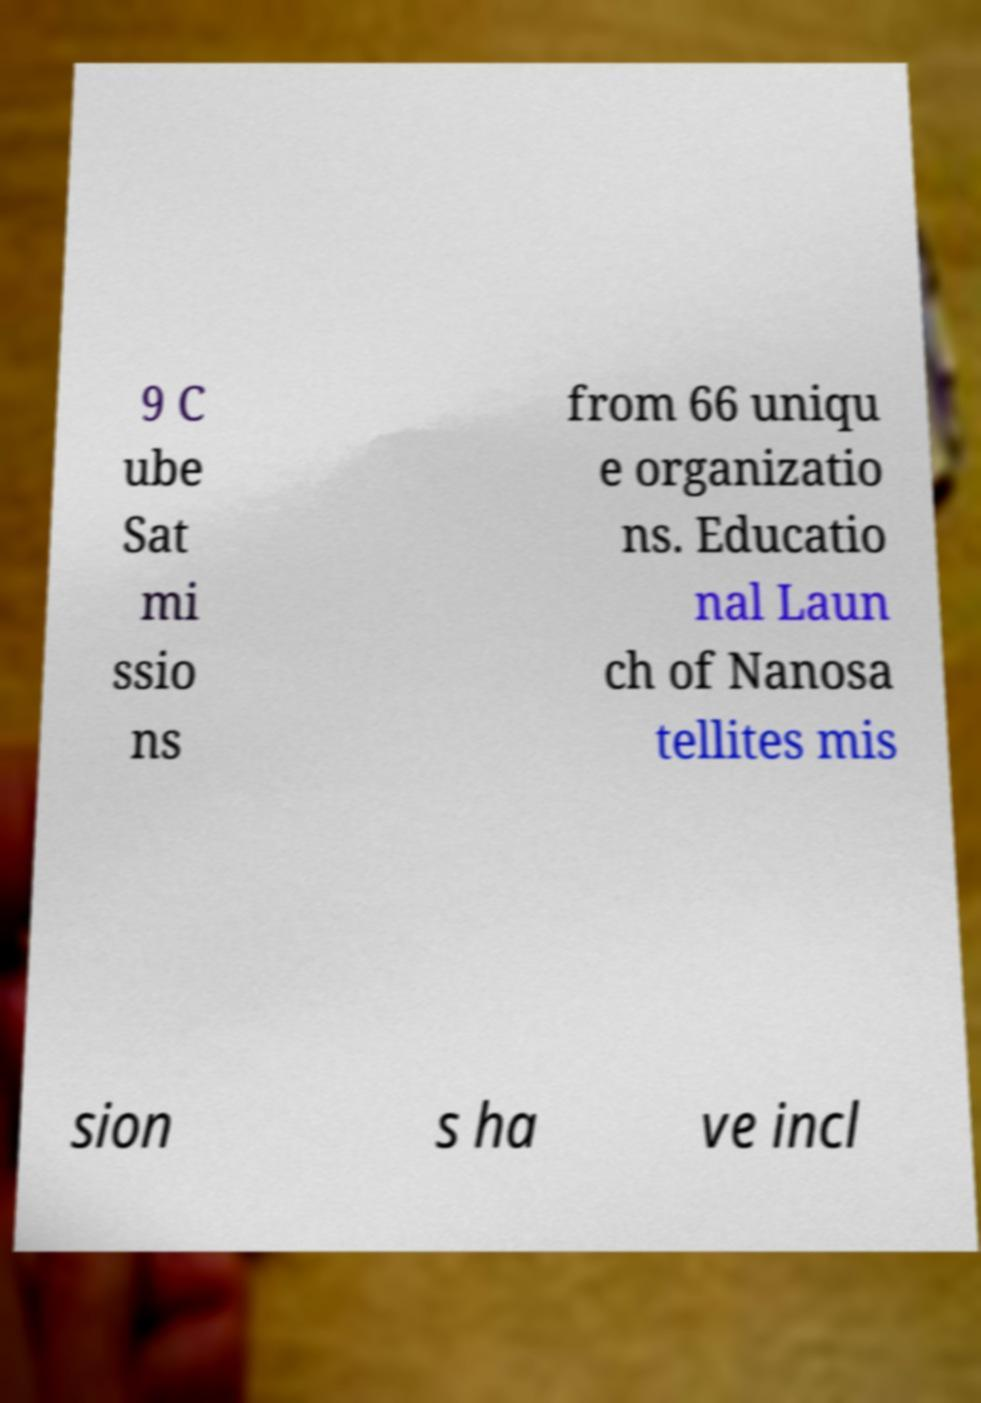Please read and relay the text visible in this image. What does it say? 9 C ube Sat mi ssio ns from 66 uniqu e organizatio ns. Educatio nal Laun ch of Nanosa tellites mis sion s ha ve incl 